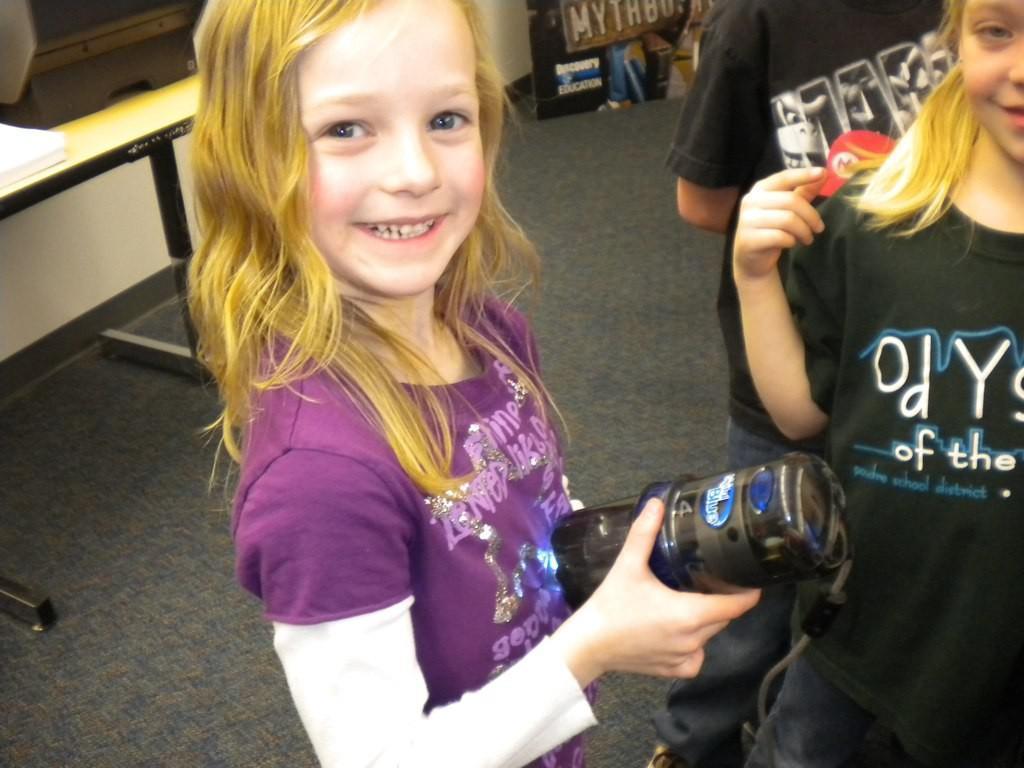How would you summarize this image in a sentence or two? In this picture there is a small girl in the center of the image, by holding a water bottle in her hands and there are other children and there is a bench in the top left side of the image. 